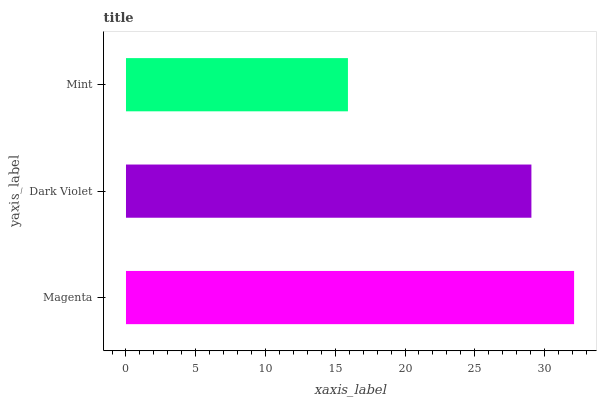Is Mint the minimum?
Answer yes or no. Yes. Is Magenta the maximum?
Answer yes or no. Yes. Is Dark Violet the minimum?
Answer yes or no. No. Is Dark Violet the maximum?
Answer yes or no. No. Is Magenta greater than Dark Violet?
Answer yes or no. Yes. Is Dark Violet less than Magenta?
Answer yes or no. Yes. Is Dark Violet greater than Magenta?
Answer yes or no. No. Is Magenta less than Dark Violet?
Answer yes or no. No. Is Dark Violet the high median?
Answer yes or no. Yes. Is Dark Violet the low median?
Answer yes or no. Yes. Is Magenta the high median?
Answer yes or no. No. Is Mint the low median?
Answer yes or no. No. 